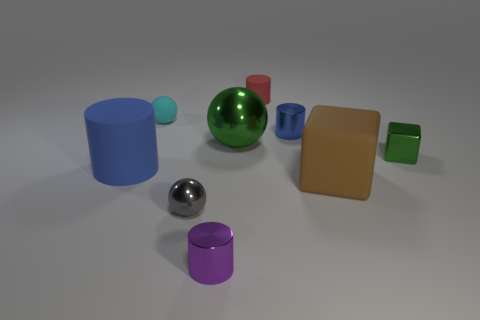There is a cylinder that is both right of the tiny cyan matte ball and left of the large metallic thing; how big is it?
Provide a succinct answer. Small. The small sphere that is the same material as the tiny green block is what color?
Provide a succinct answer. Gray. How many green objects have the same material as the small blue thing?
Your answer should be very brief. 2. Is the number of small purple things behind the big block the same as the number of green shiny blocks on the right side of the red rubber cylinder?
Your answer should be very brief. No. There is a red matte thing; is it the same shape as the green metal thing that is behind the small green metal block?
Offer a terse response. No. There is a block that is the same color as the big metal object; what is its material?
Ensure brevity in your answer.  Metal. Are there any other things that have the same shape as the small blue metallic thing?
Give a very brief answer. Yes. Do the tiny red thing and the green thing on the left side of the large matte block have the same material?
Offer a very short reply. No. What color is the shiny sphere behind the tiny object that is on the right side of the small metallic object that is behind the small green metal block?
Your answer should be compact. Green. Are there any other things that are the same size as the blue matte cylinder?
Offer a terse response. Yes. 